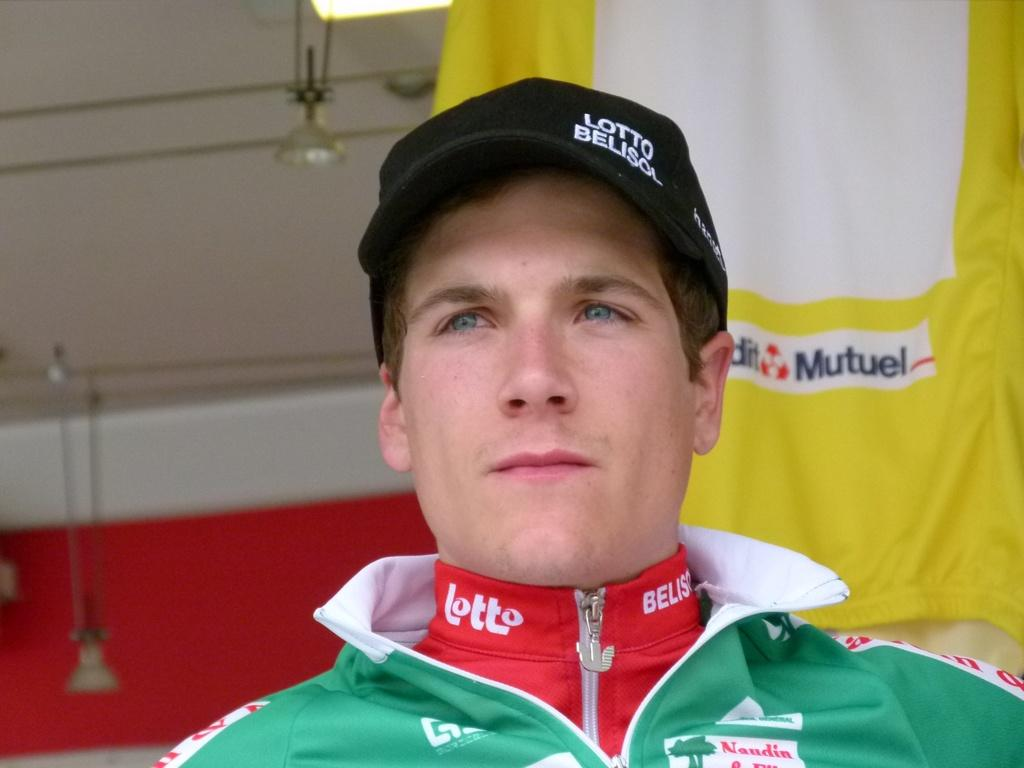Who is present in the image? There is a man in the picture. What is the man wearing on his head? The man is wearing a cap on his head. What can be seen in the background of the image? There appears to be a cloth hanging in the background. What type of lighting is present in the image? There are lights on the ceiling in the image. What type of knot is the man using to secure the cloth in the image? There is no knot visible in the image, as the cloth hanging in the background is not being secured by any visible knot. 